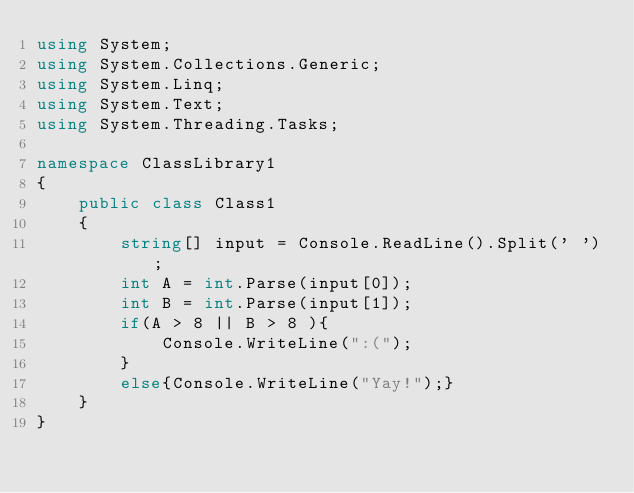<code> <loc_0><loc_0><loc_500><loc_500><_C#_>using System;
using System.Collections.Generic;
using System.Linq;
using System.Text;
using System.Threading.Tasks;

namespace ClassLibrary1
{
    public class Class1
    {
        string[] input = Console.ReadLine().Split(' ');
        int A = int.Parse(input[0]);
        int B = int.Parse(input[1]);
        if(A > 8 || B > 8 ){
            Console.WriteLine(":(");
        }
        else{Console.WriteLine("Yay!");}
    }
}</code> 